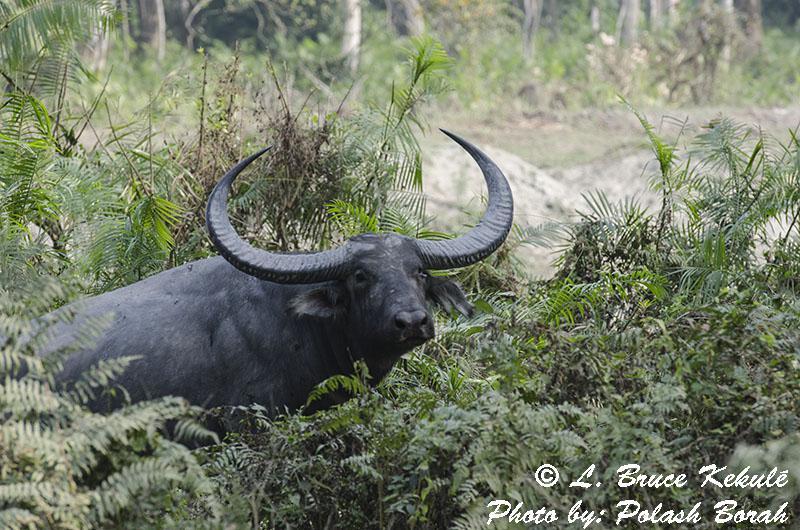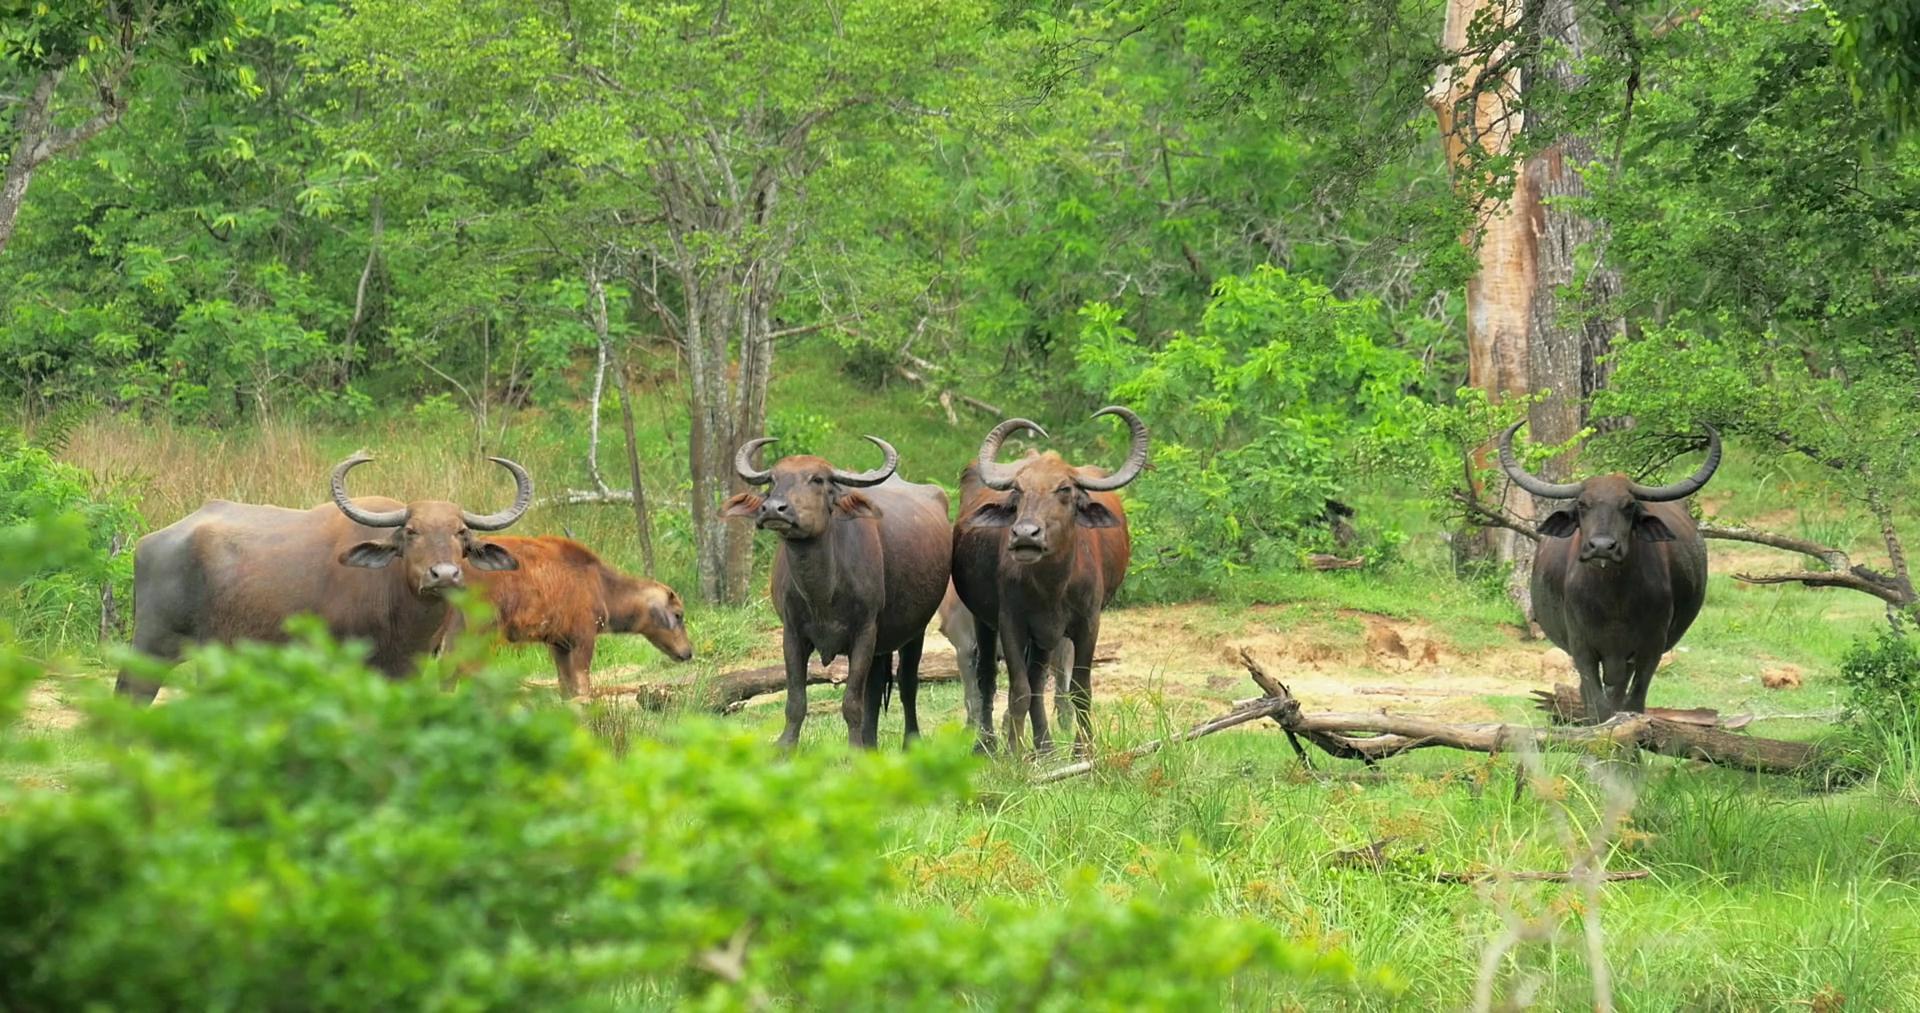The first image is the image on the left, the second image is the image on the right. For the images displayed, is the sentence "All images show water buffalo in the water, and one image shows at least one young male in the scene with water buffalo." factually correct? Answer yes or no. No. 